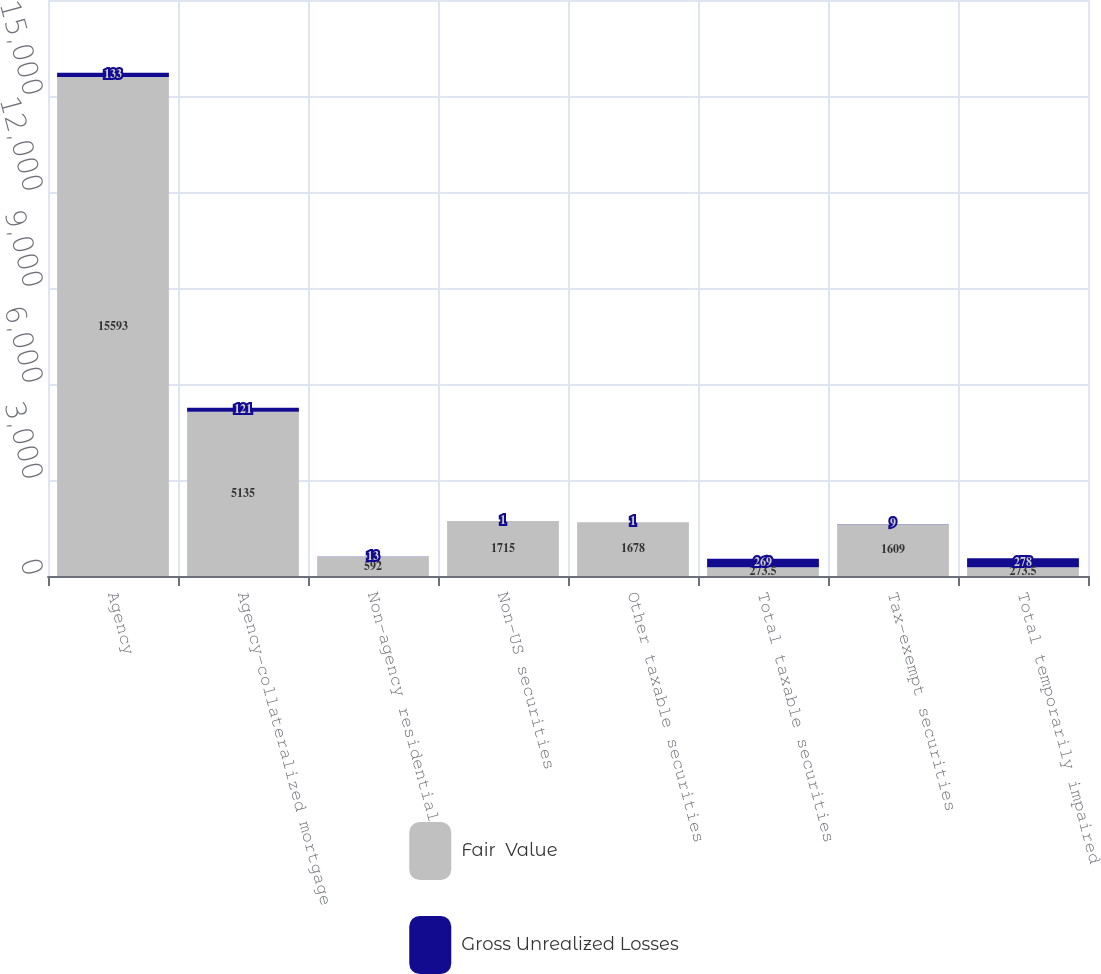Convert chart. <chart><loc_0><loc_0><loc_500><loc_500><stacked_bar_chart><ecel><fcel>Agency<fcel>Agency-collateralized mortgage<fcel>Non-agency residential<fcel>Non-US securities<fcel>Other taxable securities<fcel>Total taxable securities<fcel>Tax-exempt securities<fcel>Total temporarily impaired<nl><fcel>Fair  Value<fcel>15593<fcel>5135<fcel>592<fcel>1715<fcel>1678<fcel>273.5<fcel>1609<fcel>273.5<nl><fcel>Gross Unrealized Losses<fcel>133<fcel>121<fcel>13<fcel>1<fcel>1<fcel>269<fcel>9<fcel>278<nl></chart> 